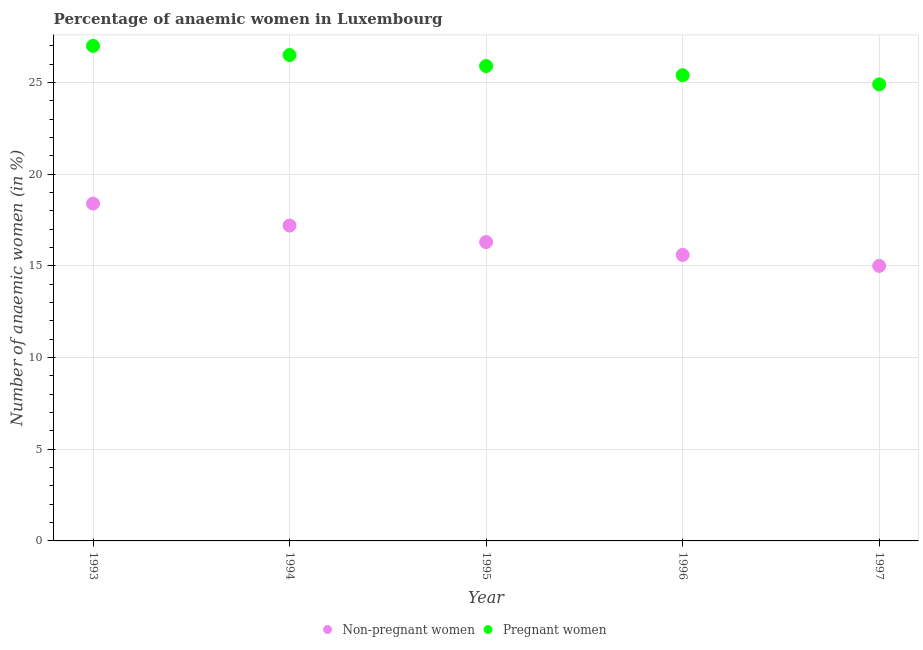Is the number of dotlines equal to the number of legend labels?
Keep it short and to the point. Yes. Across all years, what is the minimum percentage of pregnant anaemic women?
Give a very brief answer. 24.9. In which year was the percentage of non-pregnant anaemic women maximum?
Give a very brief answer. 1993. What is the total percentage of non-pregnant anaemic women in the graph?
Ensure brevity in your answer.  82.5. What is the difference between the percentage of non-pregnant anaemic women in 1994 and that in 1997?
Provide a short and direct response. 2.2. What is the difference between the percentage of non-pregnant anaemic women in 1993 and the percentage of pregnant anaemic women in 1995?
Your answer should be very brief. -7.5. What is the average percentage of pregnant anaemic women per year?
Your response must be concise. 25.94. In the year 1996, what is the difference between the percentage of pregnant anaemic women and percentage of non-pregnant anaemic women?
Your answer should be very brief. 9.8. In how many years, is the percentage of non-pregnant anaemic women greater than 25 %?
Ensure brevity in your answer.  0. What is the ratio of the percentage of pregnant anaemic women in 1993 to that in 1994?
Offer a very short reply. 1.02. Is the percentage of non-pregnant anaemic women in 1995 less than that in 1996?
Keep it short and to the point. No. Is the difference between the percentage of pregnant anaemic women in 1994 and 1997 greater than the difference between the percentage of non-pregnant anaemic women in 1994 and 1997?
Keep it short and to the point. No. What is the difference between the highest and the second highest percentage of non-pregnant anaemic women?
Your response must be concise. 1.2. What is the difference between the highest and the lowest percentage of pregnant anaemic women?
Ensure brevity in your answer.  2.1. In how many years, is the percentage of non-pregnant anaemic women greater than the average percentage of non-pregnant anaemic women taken over all years?
Keep it short and to the point. 2. Is the sum of the percentage of non-pregnant anaemic women in 1994 and 1996 greater than the maximum percentage of pregnant anaemic women across all years?
Make the answer very short. Yes. Does the percentage of non-pregnant anaemic women monotonically increase over the years?
Keep it short and to the point. No. Is the percentage of non-pregnant anaemic women strictly greater than the percentage of pregnant anaemic women over the years?
Give a very brief answer. No. Is the percentage of non-pregnant anaemic women strictly less than the percentage of pregnant anaemic women over the years?
Ensure brevity in your answer.  Yes. Does the graph contain any zero values?
Provide a short and direct response. No. How many legend labels are there?
Offer a terse response. 2. What is the title of the graph?
Give a very brief answer. Percentage of anaemic women in Luxembourg. What is the label or title of the X-axis?
Ensure brevity in your answer.  Year. What is the label or title of the Y-axis?
Your answer should be compact. Number of anaemic women (in %). What is the Number of anaemic women (in %) in Non-pregnant women in 1993?
Keep it short and to the point. 18.4. What is the Number of anaemic women (in %) of Pregnant women in 1993?
Your response must be concise. 27. What is the Number of anaemic women (in %) in Pregnant women in 1994?
Offer a very short reply. 26.5. What is the Number of anaemic women (in %) in Pregnant women in 1995?
Give a very brief answer. 25.9. What is the Number of anaemic women (in %) of Pregnant women in 1996?
Offer a terse response. 25.4. What is the Number of anaemic women (in %) of Non-pregnant women in 1997?
Offer a terse response. 15. What is the Number of anaemic women (in %) of Pregnant women in 1997?
Make the answer very short. 24.9. Across all years, what is the maximum Number of anaemic women (in %) of Non-pregnant women?
Make the answer very short. 18.4. Across all years, what is the minimum Number of anaemic women (in %) of Pregnant women?
Your answer should be very brief. 24.9. What is the total Number of anaemic women (in %) in Non-pregnant women in the graph?
Offer a terse response. 82.5. What is the total Number of anaemic women (in %) of Pregnant women in the graph?
Keep it short and to the point. 129.7. What is the difference between the Number of anaemic women (in %) of Pregnant women in 1993 and that in 1995?
Make the answer very short. 1.1. What is the difference between the Number of anaemic women (in %) in Pregnant women in 1993 and that in 1996?
Give a very brief answer. 1.6. What is the difference between the Number of anaemic women (in %) in Non-pregnant women in 1993 and that in 1997?
Keep it short and to the point. 3.4. What is the difference between the Number of anaemic women (in %) in Non-pregnant women in 1994 and that in 1997?
Provide a short and direct response. 2.2. What is the difference between the Number of anaemic women (in %) of Non-pregnant women in 1995 and that in 1997?
Provide a short and direct response. 1.3. What is the difference between the Number of anaemic women (in %) in Non-pregnant women in 1996 and that in 1997?
Your response must be concise. 0.6. What is the difference between the Number of anaemic women (in %) of Pregnant women in 1996 and that in 1997?
Make the answer very short. 0.5. What is the difference between the Number of anaemic women (in %) in Non-pregnant women in 1993 and the Number of anaemic women (in %) in Pregnant women in 1996?
Give a very brief answer. -7. What is the difference between the Number of anaemic women (in %) of Non-pregnant women in 1994 and the Number of anaemic women (in %) of Pregnant women in 1995?
Offer a very short reply. -8.7. What is the difference between the Number of anaemic women (in %) of Non-pregnant women in 1995 and the Number of anaemic women (in %) of Pregnant women in 1996?
Offer a terse response. -9.1. What is the average Number of anaemic women (in %) of Pregnant women per year?
Ensure brevity in your answer.  25.94. In the year 1993, what is the difference between the Number of anaemic women (in %) of Non-pregnant women and Number of anaemic women (in %) of Pregnant women?
Your answer should be very brief. -8.6. In the year 1994, what is the difference between the Number of anaemic women (in %) in Non-pregnant women and Number of anaemic women (in %) in Pregnant women?
Give a very brief answer. -9.3. In the year 1995, what is the difference between the Number of anaemic women (in %) of Non-pregnant women and Number of anaemic women (in %) of Pregnant women?
Ensure brevity in your answer.  -9.6. In the year 1997, what is the difference between the Number of anaemic women (in %) in Non-pregnant women and Number of anaemic women (in %) in Pregnant women?
Your answer should be compact. -9.9. What is the ratio of the Number of anaemic women (in %) of Non-pregnant women in 1993 to that in 1994?
Provide a succinct answer. 1.07. What is the ratio of the Number of anaemic women (in %) of Pregnant women in 1993 to that in 1994?
Ensure brevity in your answer.  1.02. What is the ratio of the Number of anaemic women (in %) in Non-pregnant women in 1993 to that in 1995?
Make the answer very short. 1.13. What is the ratio of the Number of anaemic women (in %) in Pregnant women in 1993 to that in 1995?
Offer a very short reply. 1.04. What is the ratio of the Number of anaemic women (in %) of Non-pregnant women in 1993 to that in 1996?
Give a very brief answer. 1.18. What is the ratio of the Number of anaemic women (in %) in Pregnant women in 1993 to that in 1996?
Your response must be concise. 1.06. What is the ratio of the Number of anaemic women (in %) in Non-pregnant women in 1993 to that in 1997?
Your response must be concise. 1.23. What is the ratio of the Number of anaemic women (in %) of Pregnant women in 1993 to that in 1997?
Your answer should be very brief. 1.08. What is the ratio of the Number of anaemic women (in %) of Non-pregnant women in 1994 to that in 1995?
Provide a short and direct response. 1.06. What is the ratio of the Number of anaemic women (in %) of Pregnant women in 1994 to that in 1995?
Your answer should be very brief. 1.02. What is the ratio of the Number of anaemic women (in %) in Non-pregnant women in 1994 to that in 1996?
Give a very brief answer. 1.1. What is the ratio of the Number of anaemic women (in %) of Pregnant women in 1994 to that in 1996?
Ensure brevity in your answer.  1.04. What is the ratio of the Number of anaemic women (in %) of Non-pregnant women in 1994 to that in 1997?
Your answer should be very brief. 1.15. What is the ratio of the Number of anaemic women (in %) of Pregnant women in 1994 to that in 1997?
Offer a terse response. 1.06. What is the ratio of the Number of anaemic women (in %) of Non-pregnant women in 1995 to that in 1996?
Keep it short and to the point. 1.04. What is the ratio of the Number of anaemic women (in %) in Pregnant women in 1995 to that in 1996?
Provide a succinct answer. 1.02. What is the ratio of the Number of anaemic women (in %) in Non-pregnant women in 1995 to that in 1997?
Your response must be concise. 1.09. What is the ratio of the Number of anaemic women (in %) in Pregnant women in 1995 to that in 1997?
Offer a very short reply. 1.04. What is the ratio of the Number of anaemic women (in %) of Pregnant women in 1996 to that in 1997?
Ensure brevity in your answer.  1.02. What is the difference between the highest and the second highest Number of anaemic women (in %) in Non-pregnant women?
Provide a succinct answer. 1.2. What is the difference between the highest and the lowest Number of anaemic women (in %) in Non-pregnant women?
Your answer should be compact. 3.4. 